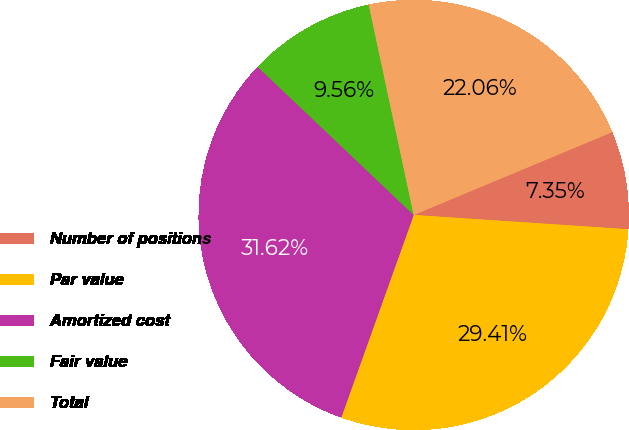<chart> <loc_0><loc_0><loc_500><loc_500><pie_chart><fcel>Number of positions<fcel>Par value<fcel>Amortized cost<fcel>Fair value<fcel>Total<nl><fcel>7.35%<fcel>29.41%<fcel>31.62%<fcel>9.56%<fcel>22.06%<nl></chart> 